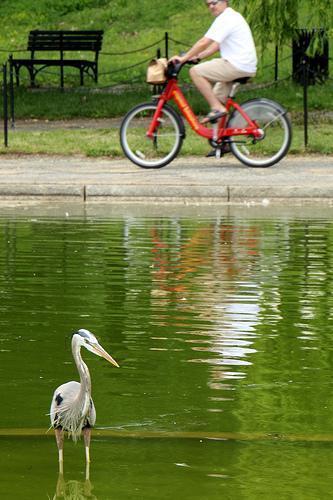How many people do you see?
Give a very brief answer. 1. 